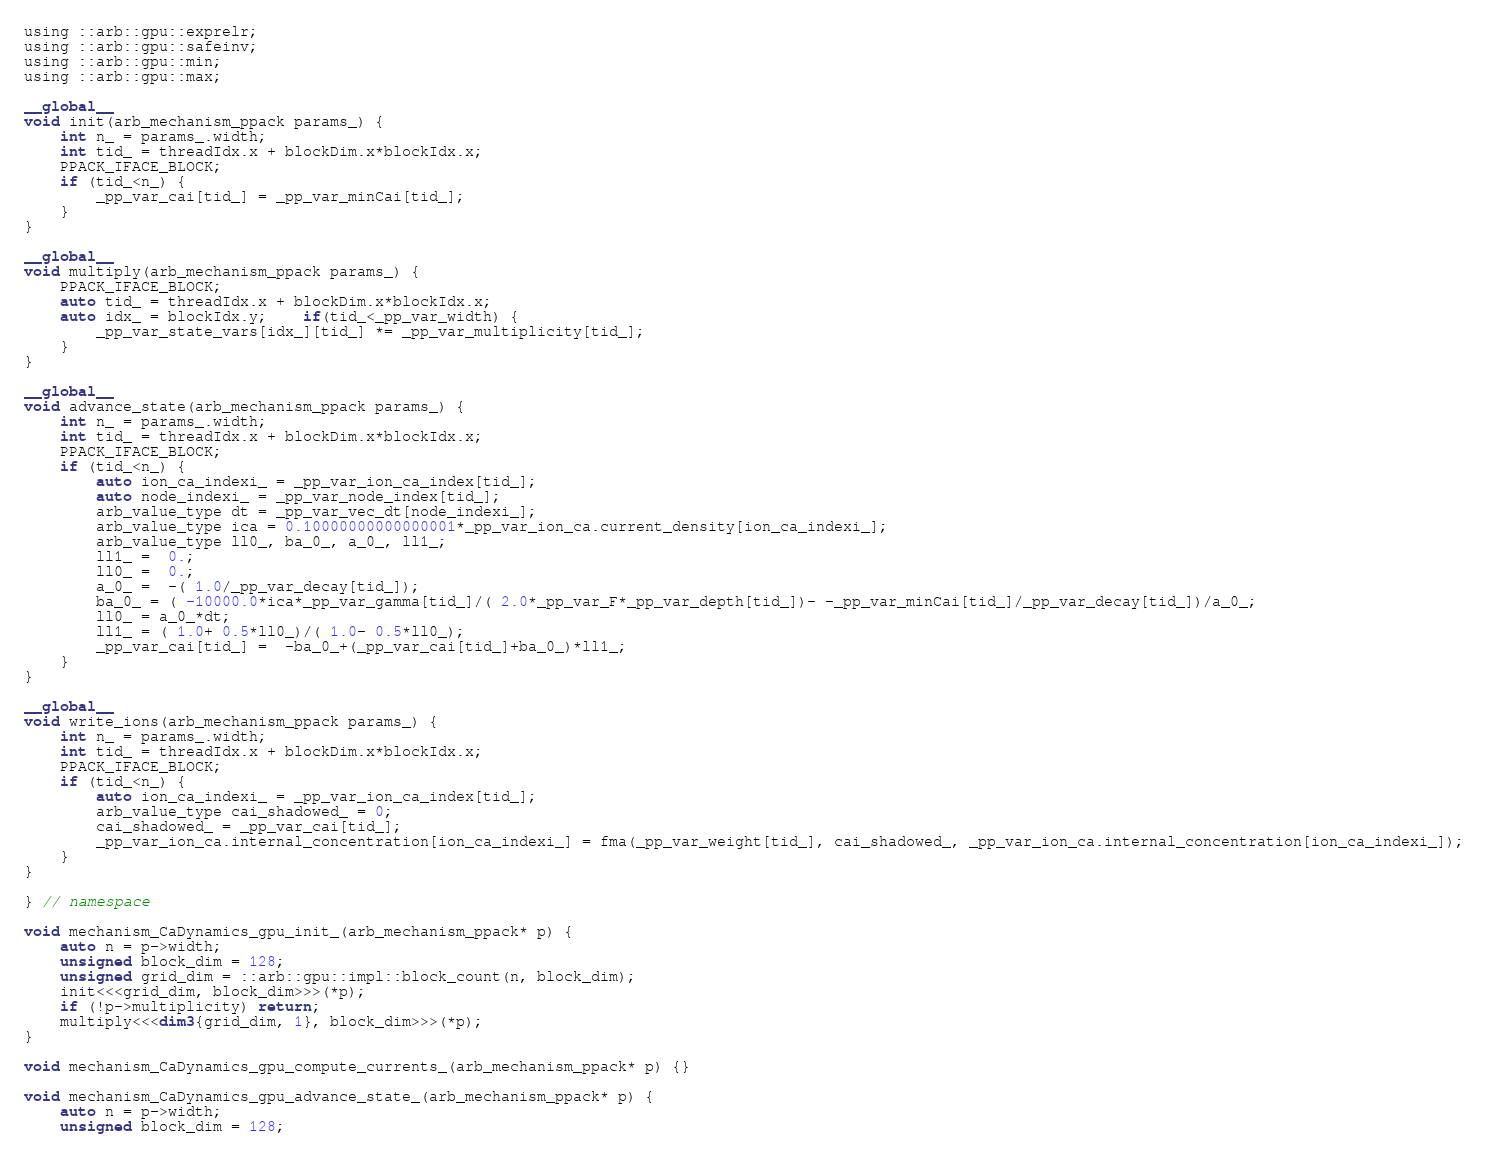<code> <loc_0><loc_0><loc_500><loc_500><_Cuda_>using ::arb::gpu::exprelr;
using ::arb::gpu::safeinv;
using ::arb::gpu::min;
using ::arb::gpu::max;

__global__
void init(arb_mechanism_ppack params_) {
    int n_ = params_.width;
    int tid_ = threadIdx.x + blockDim.x*blockIdx.x;
    PPACK_IFACE_BLOCK;
    if (tid_<n_) {
        _pp_var_cai[tid_] = _pp_var_minCai[tid_];
    }
}

__global__
void multiply(arb_mechanism_ppack params_) {
    PPACK_IFACE_BLOCK;
    auto tid_ = threadIdx.x + blockDim.x*blockIdx.x;
    auto idx_ = blockIdx.y;    if(tid_<_pp_var_width) {
        _pp_var_state_vars[idx_][tid_] *= _pp_var_multiplicity[tid_];
    }
}

__global__
void advance_state(arb_mechanism_ppack params_) {
    int n_ = params_.width;
    int tid_ = threadIdx.x + blockDim.x*blockIdx.x;
    PPACK_IFACE_BLOCK;
    if (tid_<n_) {
        auto ion_ca_indexi_ = _pp_var_ion_ca_index[tid_];
        auto node_indexi_ = _pp_var_node_index[tid_];
        arb_value_type dt = _pp_var_vec_dt[node_indexi_];
        arb_value_type ica = 0.10000000000000001*_pp_var_ion_ca.current_density[ion_ca_indexi_];
        arb_value_type ll0_, ba_0_, a_0_, ll1_;
        ll1_ =  0.;
        ll0_ =  0.;
        a_0_ =  -( 1.0/_pp_var_decay[tid_]);
        ba_0_ = ( -10000.0*ica*_pp_var_gamma[tid_]/( 2.0*_pp_var_F*_pp_var_depth[tid_])- -_pp_var_minCai[tid_]/_pp_var_decay[tid_])/a_0_;
        ll0_ = a_0_*dt;
        ll1_ = ( 1.0+ 0.5*ll0_)/( 1.0- 0.5*ll0_);
        _pp_var_cai[tid_] =  -ba_0_+(_pp_var_cai[tid_]+ba_0_)*ll1_;
    }
}

__global__
void write_ions(arb_mechanism_ppack params_) {
    int n_ = params_.width;
    int tid_ = threadIdx.x + blockDim.x*blockIdx.x;
    PPACK_IFACE_BLOCK;
    if (tid_<n_) {
        auto ion_ca_indexi_ = _pp_var_ion_ca_index[tid_];
        arb_value_type cai_shadowed_ = 0;
        cai_shadowed_ = _pp_var_cai[tid_];
        _pp_var_ion_ca.internal_concentration[ion_ca_indexi_] = fma(_pp_var_weight[tid_], cai_shadowed_, _pp_var_ion_ca.internal_concentration[ion_ca_indexi_]);
    }
}

} // namespace

void mechanism_CaDynamics_gpu_init_(arb_mechanism_ppack* p) {
    auto n = p->width;
    unsigned block_dim = 128;
    unsigned grid_dim = ::arb::gpu::impl::block_count(n, block_dim);
    init<<<grid_dim, block_dim>>>(*p);
    if (!p->multiplicity) return;
    multiply<<<dim3{grid_dim, 1}, block_dim>>>(*p);
}

void mechanism_CaDynamics_gpu_compute_currents_(arb_mechanism_ppack* p) {}

void mechanism_CaDynamics_gpu_advance_state_(arb_mechanism_ppack* p) {
    auto n = p->width;
    unsigned block_dim = 128;</code> 